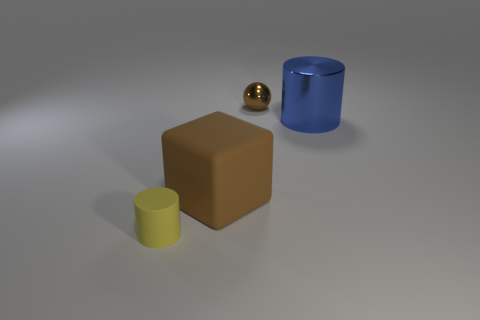What is the material of the tiny thing that is the same shape as the large blue metallic object?
Offer a very short reply. Rubber. What number of brown metal things are in front of the thing that is to the left of the rubber object that is behind the tiny yellow thing?
Ensure brevity in your answer.  0. Are there any other things that have the same color as the rubber block?
Provide a short and direct response. Yes. What number of small objects are left of the large brown cube and behind the blue cylinder?
Ensure brevity in your answer.  0. Do the cylinder that is left of the small shiny sphere and the brown object that is behind the big block have the same size?
Your answer should be compact. Yes. How many objects are either things that are behind the big shiny object or brown rubber objects?
Your response must be concise. 2. What material is the object that is left of the rubber cube?
Offer a very short reply. Rubber. What is the brown ball made of?
Offer a very short reply. Metal. There is a big object that is left of the thing that is on the right side of the small object right of the small rubber cylinder; what is its material?
Provide a succinct answer. Rubber. Is there anything else that has the same material as the tiny cylinder?
Keep it short and to the point. Yes. 